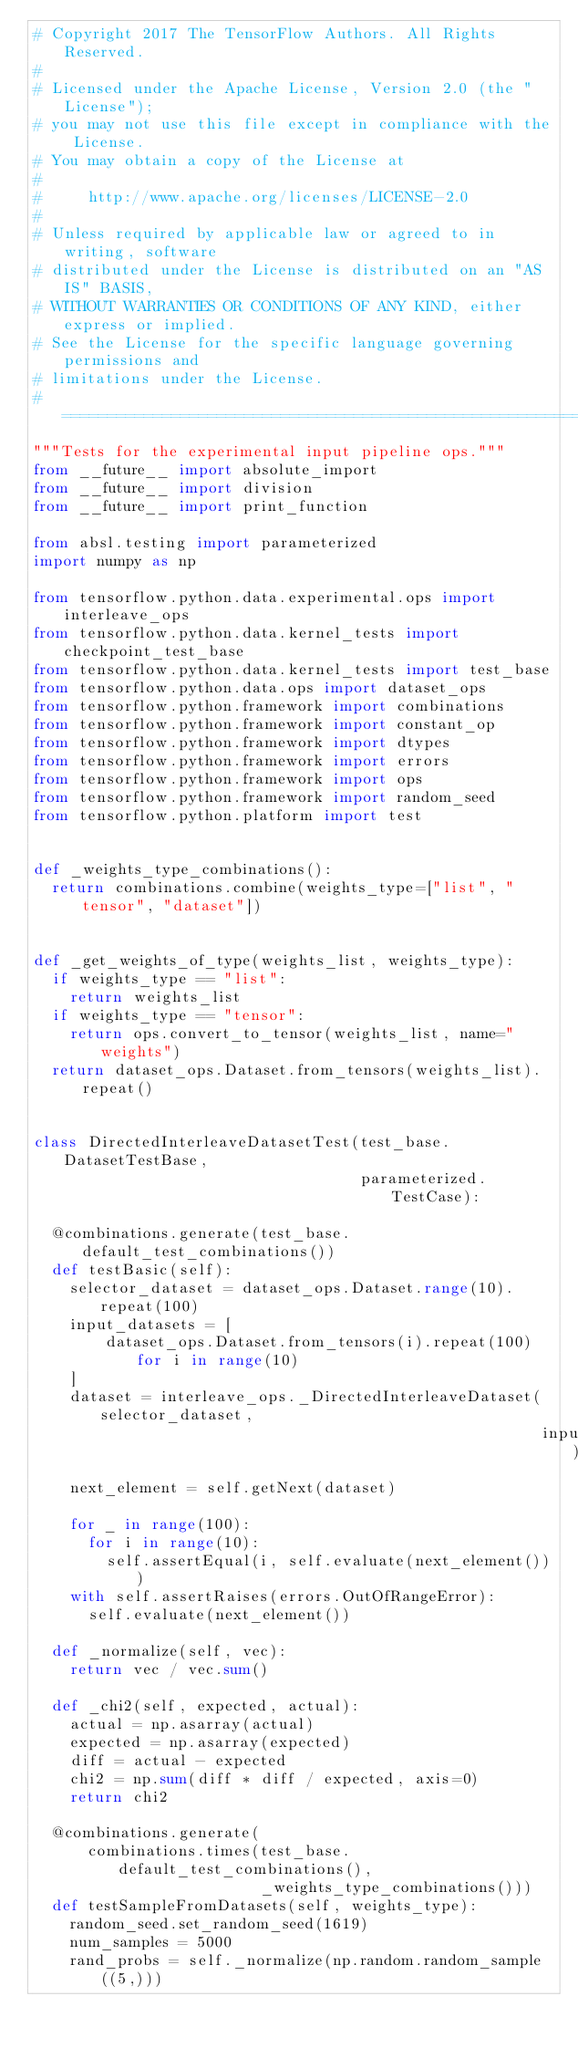Convert code to text. <code><loc_0><loc_0><loc_500><loc_500><_Python_># Copyright 2017 The TensorFlow Authors. All Rights Reserved.
#
# Licensed under the Apache License, Version 2.0 (the "License");
# you may not use this file except in compliance with the License.
# You may obtain a copy of the License at
#
#     http://www.apache.org/licenses/LICENSE-2.0
#
# Unless required by applicable law or agreed to in writing, software
# distributed under the License is distributed on an "AS IS" BASIS,
# WITHOUT WARRANTIES OR CONDITIONS OF ANY KIND, either express or implied.
# See the License for the specific language governing permissions and
# limitations under the License.
# ==============================================================================
"""Tests for the experimental input pipeline ops."""
from __future__ import absolute_import
from __future__ import division
from __future__ import print_function

from absl.testing import parameterized
import numpy as np

from tensorflow.python.data.experimental.ops import interleave_ops
from tensorflow.python.data.kernel_tests import checkpoint_test_base
from tensorflow.python.data.kernel_tests import test_base
from tensorflow.python.data.ops import dataset_ops
from tensorflow.python.framework import combinations
from tensorflow.python.framework import constant_op
from tensorflow.python.framework import dtypes
from tensorflow.python.framework import errors
from tensorflow.python.framework import ops
from tensorflow.python.framework import random_seed
from tensorflow.python.platform import test


def _weights_type_combinations():
  return combinations.combine(weights_type=["list", "tensor", "dataset"])


def _get_weights_of_type(weights_list, weights_type):
  if weights_type == "list":
    return weights_list
  if weights_type == "tensor":
    return ops.convert_to_tensor(weights_list, name="weights")
  return dataset_ops.Dataset.from_tensors(weights_list).repeat()


class DirectedInterleaveDatasetTest(test_base.DatasetTestBase,
                                    parameterized.TestCase):

  @combinations.generate(test_base.default_test_combinations())
  def testBasic(self):
    selector_dataset = dataset_ops.Dataset.range(10).repeat(100)
    input_datasets = [
        dataset_ops.Dataset.from_tensors(i).repeat(100) for i in range(10)
    ]
    dataset = interleave_ops._DirectedInterleaveDataset(selector_dataset,
                                                        input_datasets)
    next_element = self.getNext(dataset)

    for _ in range(100):
      for i in range(10):
        self.assertEqual(i, self.evaluate(next_element()))
    with self.assertRaises(errors.OutOfRangeError):
      self.evaluate(next_element())

  def _normalize(self, vec):
    return vec / vec.sum()

  def _chi2(self, expected, actual):
    actual = np.asarray(actual)
    expected = np.asarray(expected)
    diff = actual - expected
    chi2 = np.sum(diff * diff / expected, axis=0)
    return chi2

  @combinations.generate(
      combinations.times(test_base.default_test_combinations(),
                         _weights_type_combinations()))
  def testSampleFromDatasets(self, weights_type):
    random_seed.set_random_seed(1619)
    num_samples = 5000
    rand_probs = self._normalize(np.random.random_sample((5,)))
</code> 